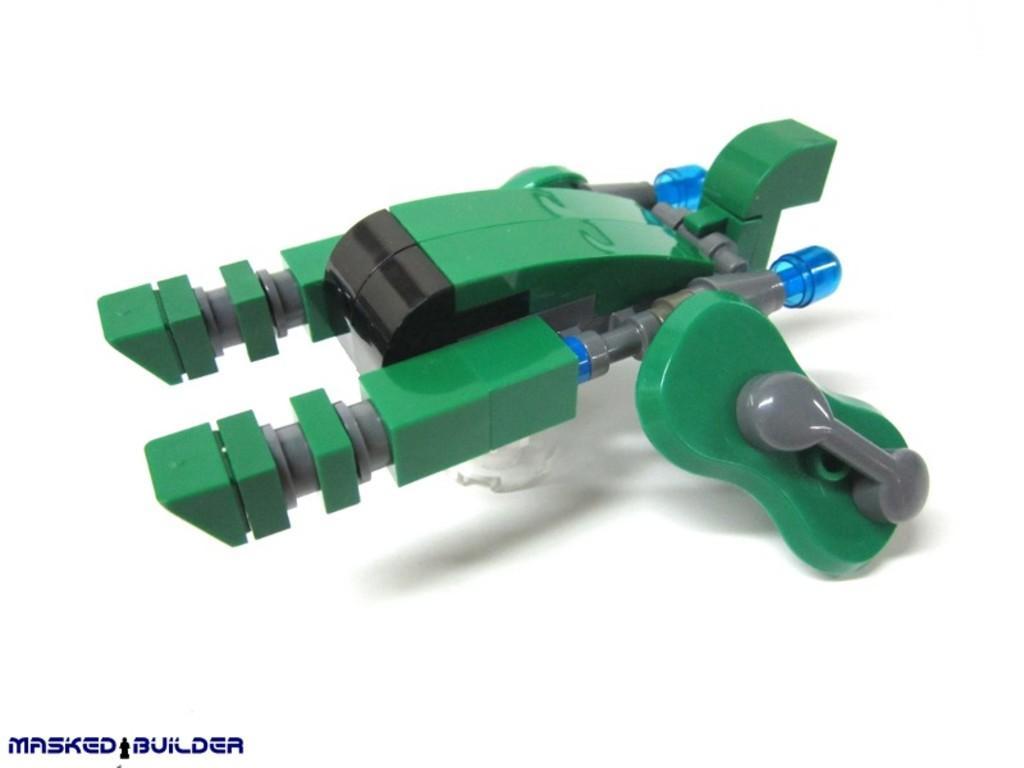How would you summarize this image in a sentence or two? This image consists of a toy in green color. It looks like a machine. At the bottom, there is a text. 